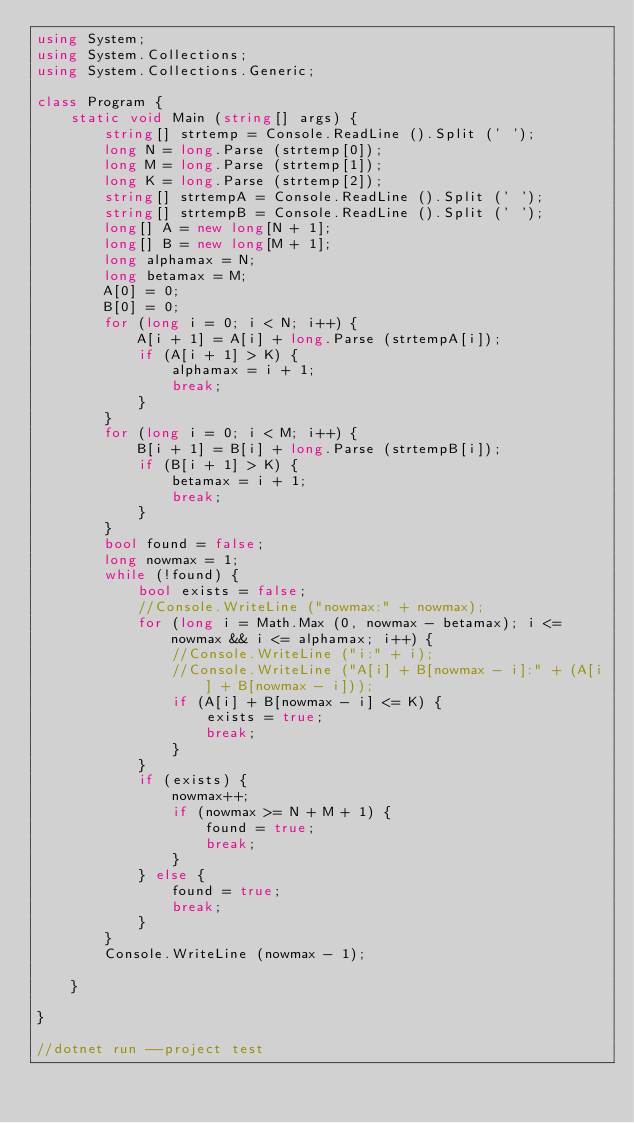Convert code to text. <code><loc_0><loc_0><loc_500><loc_500><_C#_>using System;
using System.Collections;
using System.Collections.Generic;

class Program {
    static void Main (string[] args) {
        string[] strtemp = Console.ReadLine ().Split (' ');
        long N = long.Parse (strtemp[0]);
        long M = long.Parse (strtemp[1]);
        long K = long.Parse (strtemp[2]);
        string[] strtempA = Console.ReadLine ().Split (' ');
        string[] strtempB = Console.ReadLine ().Split (' ');
        long[] A = new long[N + 1];
        long[] B = new long[M + 1];
        long alphamax = N;
        long betamax = M;
        A[0] = 0;
        B[0] = 0;
        for (long i = 0; i < N; i++) {
            A[i + 1] = A[i] + long.Parse (strtempA[i]);
            if (A[i + 1] > K) {
                alphamax = i + 1;
                break;
            }
        }
        for (long i = 0; i < M; i++) {
            B[i + 1] = B[i] + long.Parse (strtempB[i]);
            if (B[i + 1] > K) {
                betamax = i + 1;
                break;
            }
        }
        bool found = false;
        long nowmax = 1;
        while (!found) {
            bool exists = false;
            //Console.WriteLine ("nowmax:" + nowmax);
            for (long i = Math.Max (0, nowmax - betamax); i <= nowmax && i <= alphamax; i++) {
                //Console.WriteLine ("i:" + i);
                //Console.WriteLine ("A[i] + B[nowmax - i]:" + (A[i] + B[nowmax - i]));
                if (A[i] + B[nowmax - i] <= K) {
                    exists = true;
                    break;
                }
            }
            if (exists) {
                nowmax++;
                if (nowmax >= N + M + 1) {
                    found = true;
                    break;
                }
            } else {
                found = true;
                break;
            }
        }
        Console.WriteLine (nowmax - 1);

    }

}

//dotnet run --project test</code> 